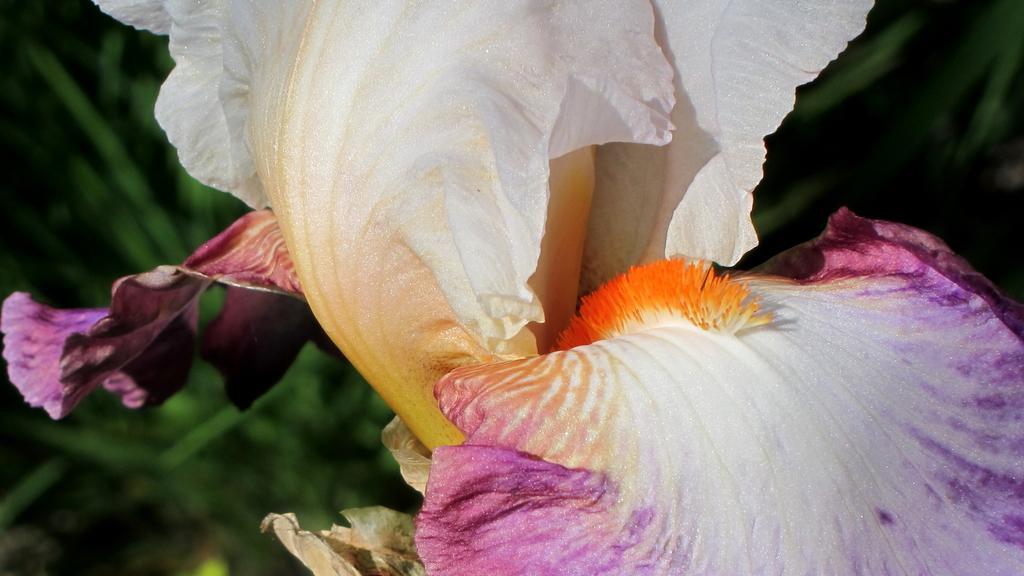Could you give a brief overview of what you see in this image? In this image, these look like the flower petals, which is white and violet in color. The background looks green in color. 